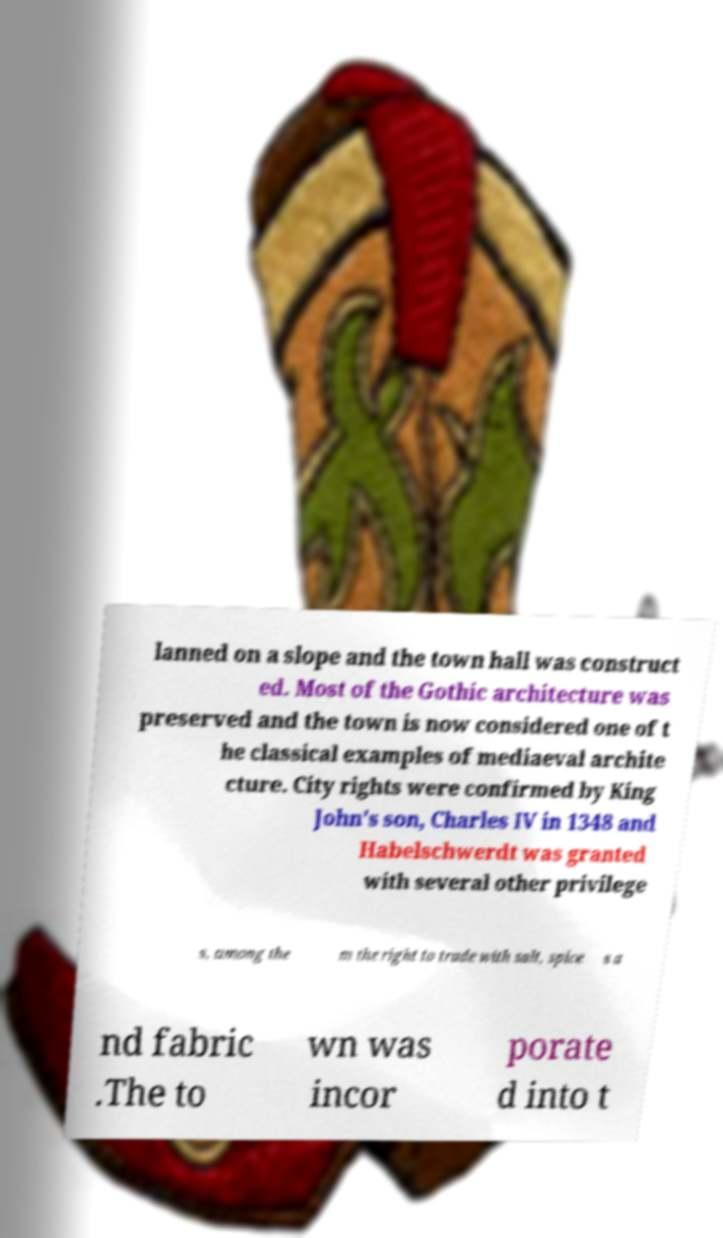What messages or text are displayed in this image? I need them in a readable, typed format. lanned on a slope and the town hall was construct ed. Most of the Gothic architecture was preserved and the town is now considered one of t he classical examples of mediaeval archite cture. City rights were confirmed by King John's son, Charles IV in 1348 and Habelschwerdt was granted with several other privilege s, among the m the right to trade with salt, spice s a nd fabric .The to wn was incor porate d into t 